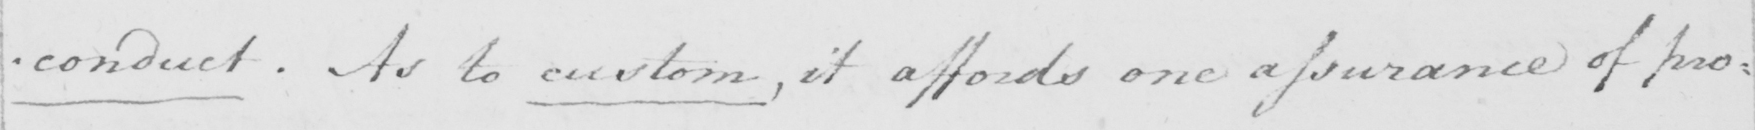What does this handwritten line say? -conduct . As to custom , it affords one assurance of pro= 